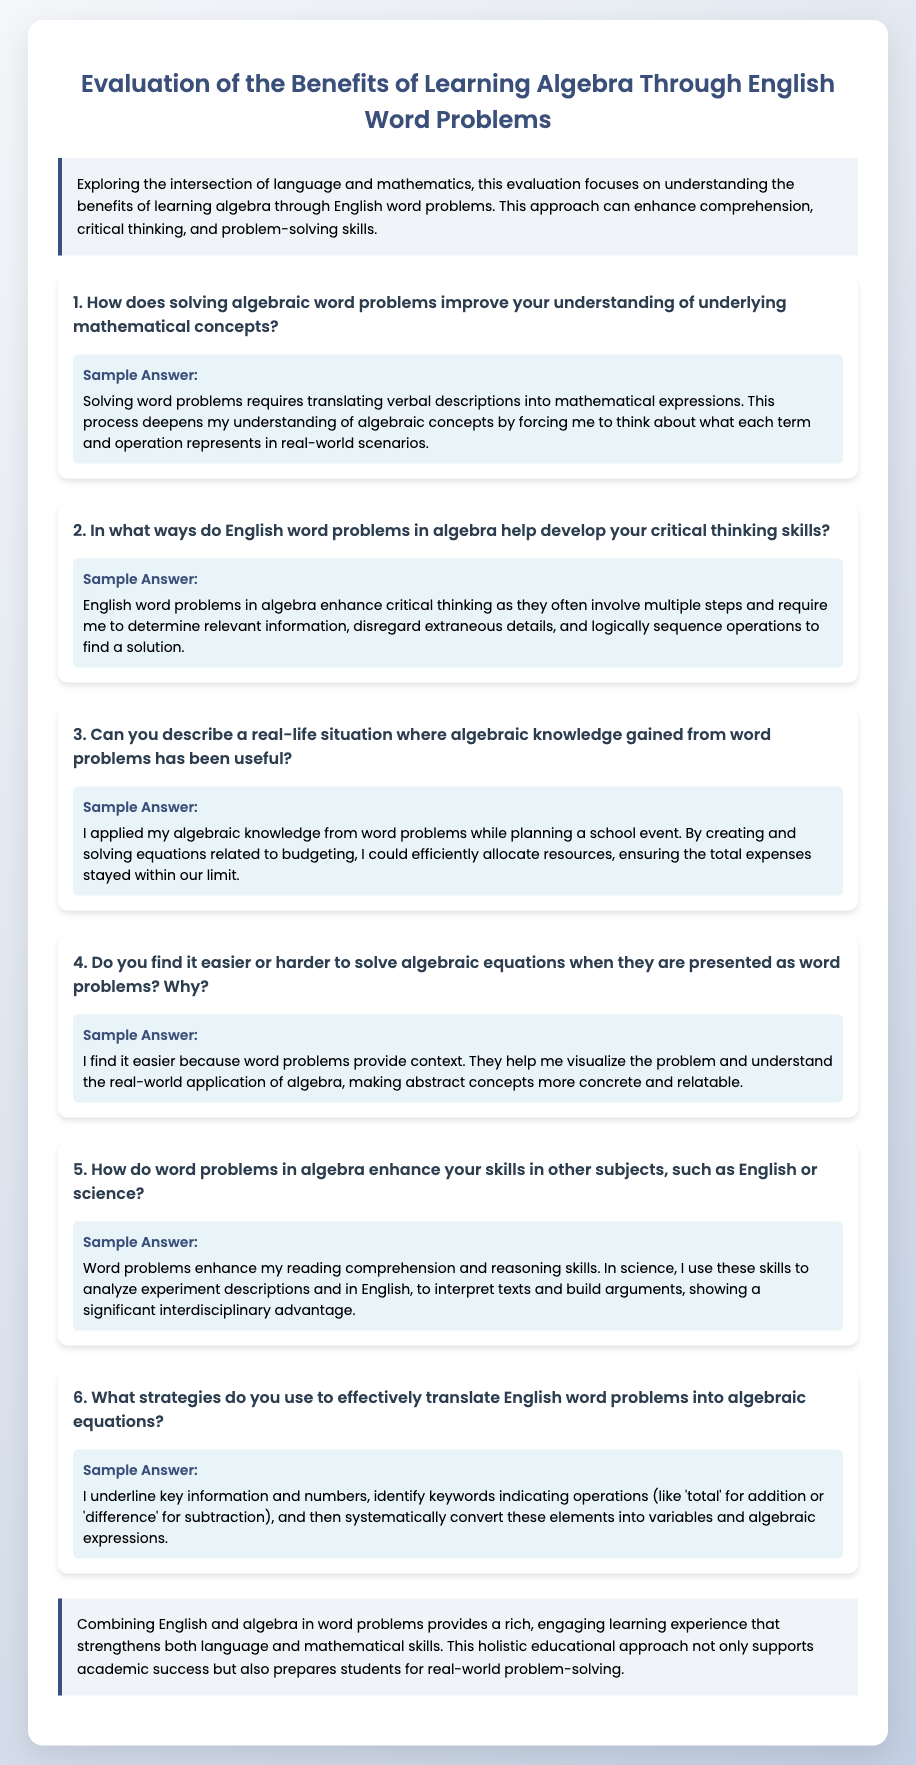What is the title of the questionnaire? The title is the main heading of the document, summarizing its focus and purpose.
Answer: Evaluation of the Benefits of Learning Algebra Through English Word Problems How many questions are included in the document? The document lists a total of six specific questions, which address various aspects of learning algebra through word problems.
Answer: 6 What is mentioned as a benefit of solving algebraic word problems? The document highlights several advantages of solving word problems, indicating that they deepen understanding of concepts.
Answer: Understanding of underlying mathematical concepts What key strategy is suggested for translating word problems into algebra? The document provides a specific method for effectively translating the problems, which includes identifying important details and indicating operations.
Answer: Underline key information and numbers Which two subjects are mentioned that benefit from algebra word problems? The document explicitly states how skills gained from word problems enhance learning in other subjects.
Answer: English and science What does the conclusion emphasize about the combination of English and algebra? The conclusion summarizes the overall impact and educational value of integrating both subjects in learning experiences.
Answer: Rich, engaging learning experience 